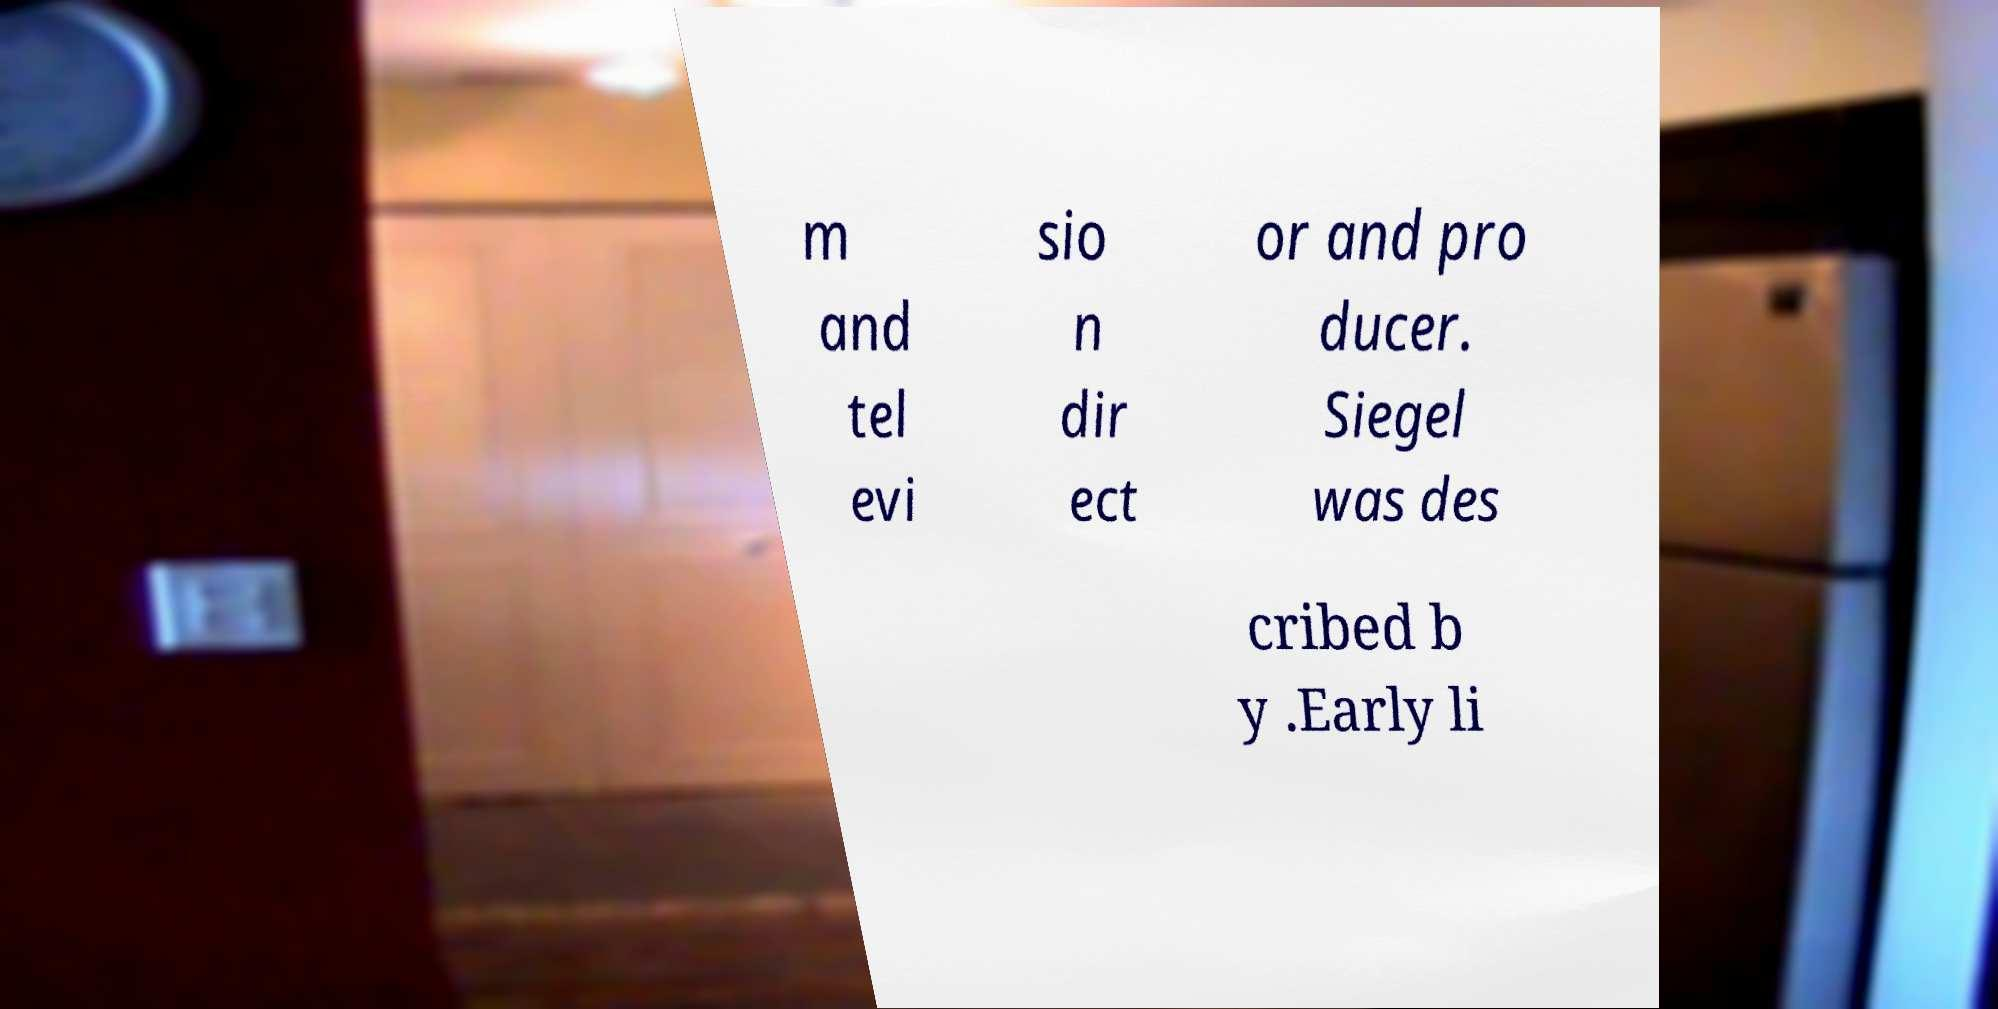Please read and relay the text visible in this image. What does it say? m and tel evi sio n dir ect or and pro ducer. Siegel was des cribed b y .Early li 